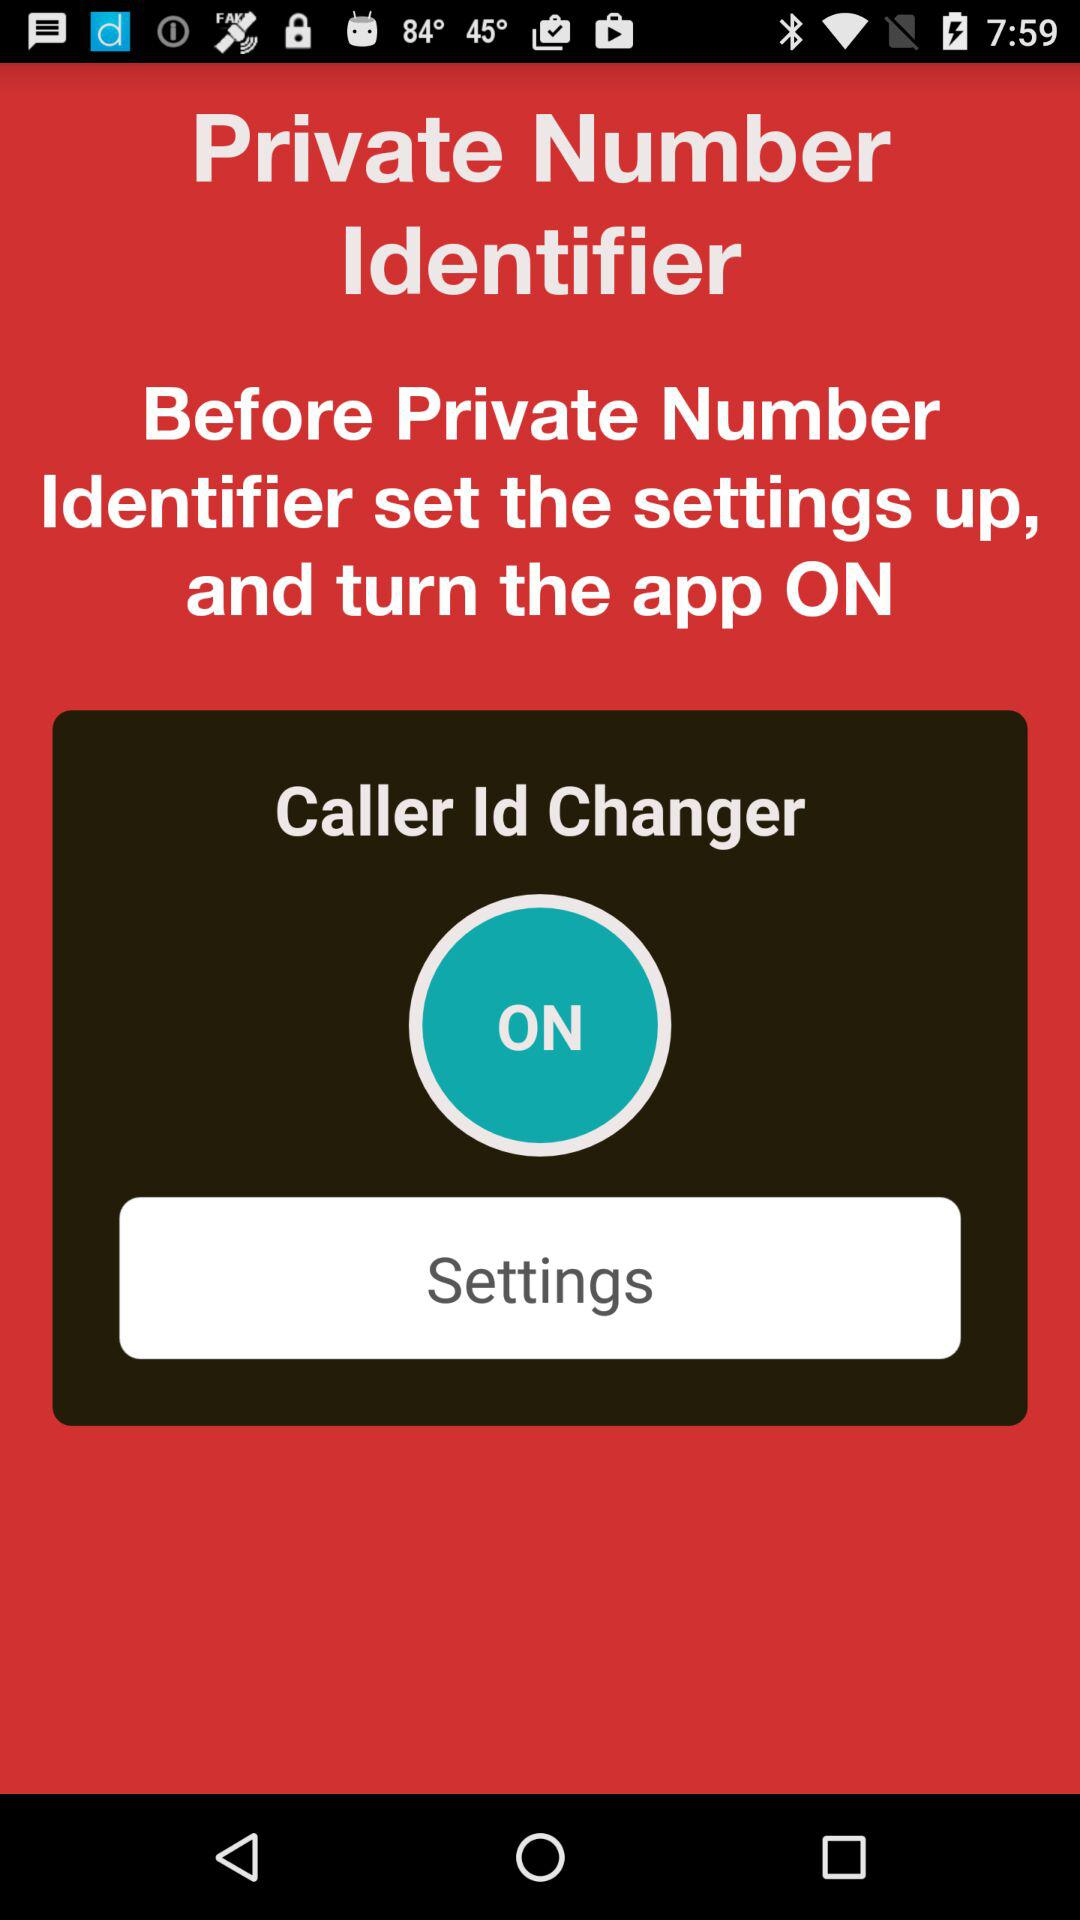What is the user's name?
When the provided information is insufficient, respond with <no answer>. <no answer> 